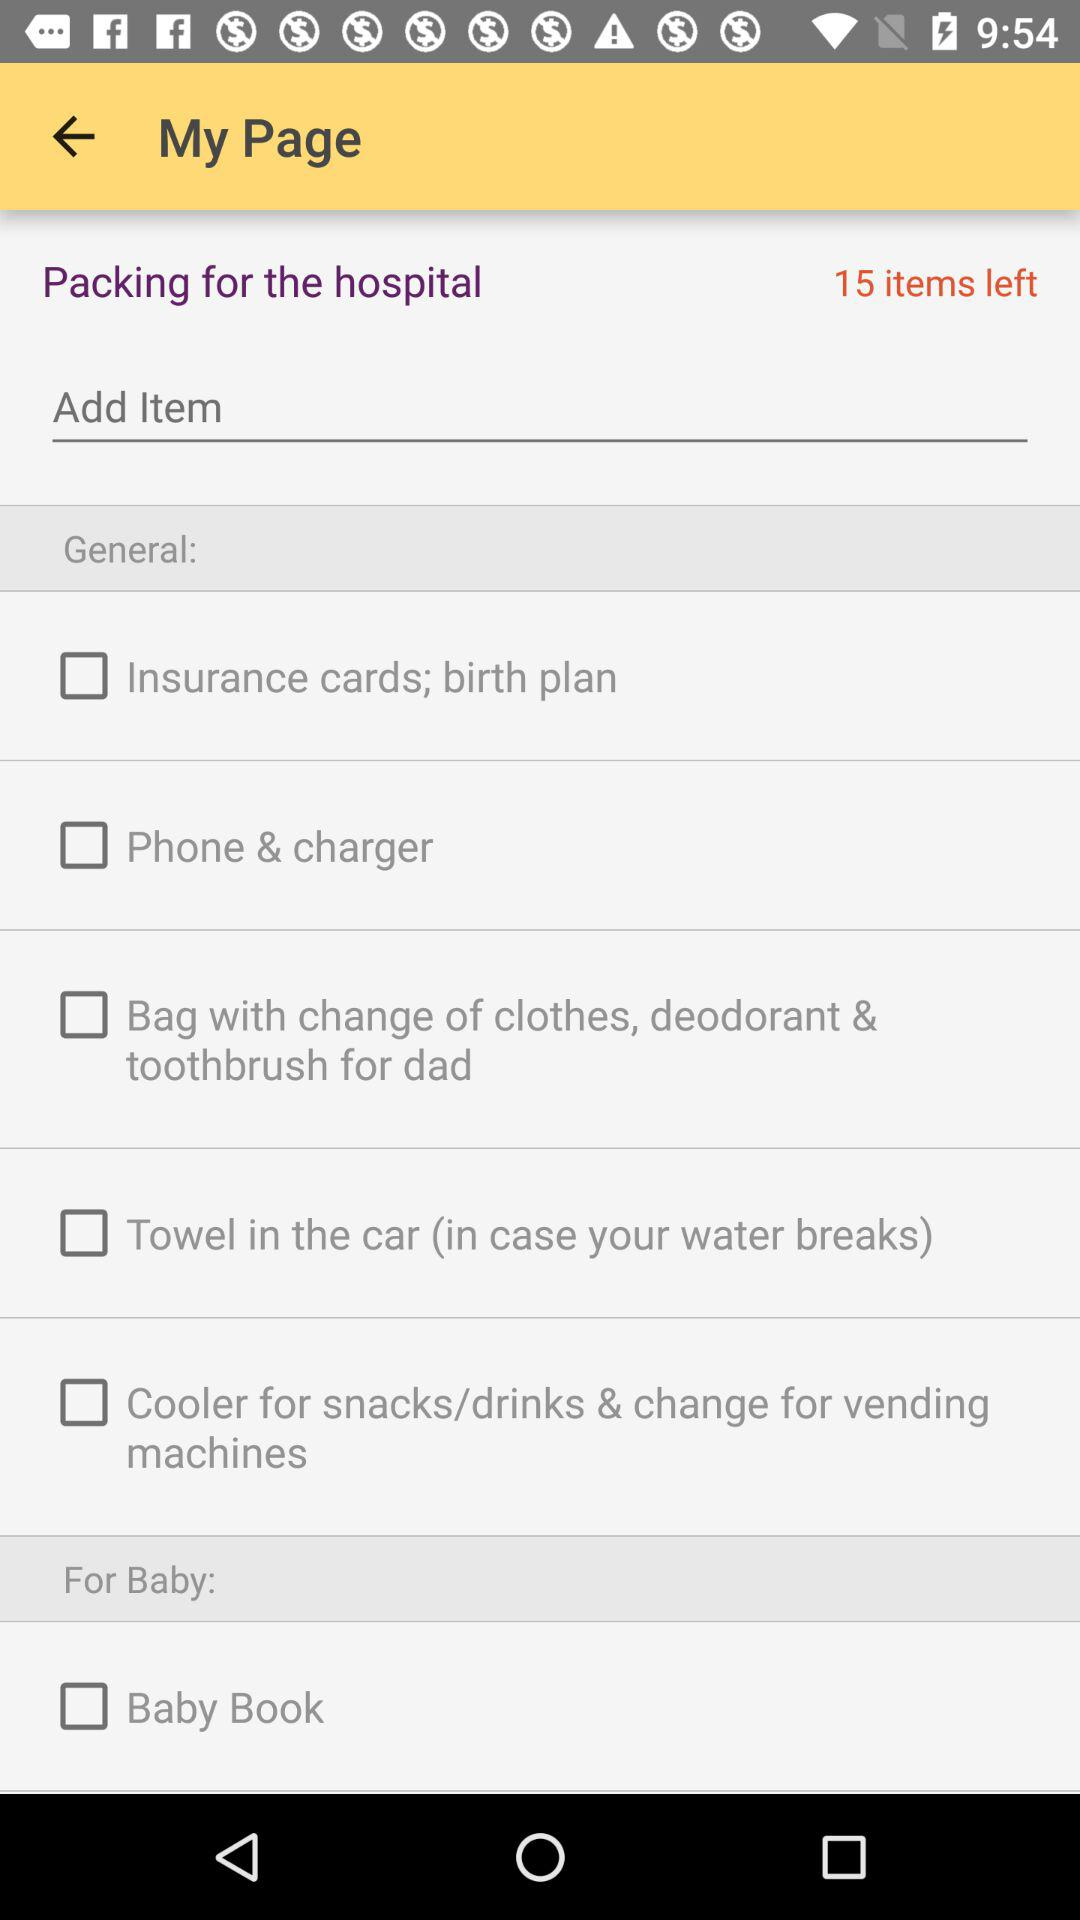How many items are left for packing? There are 15 items left to pack. 